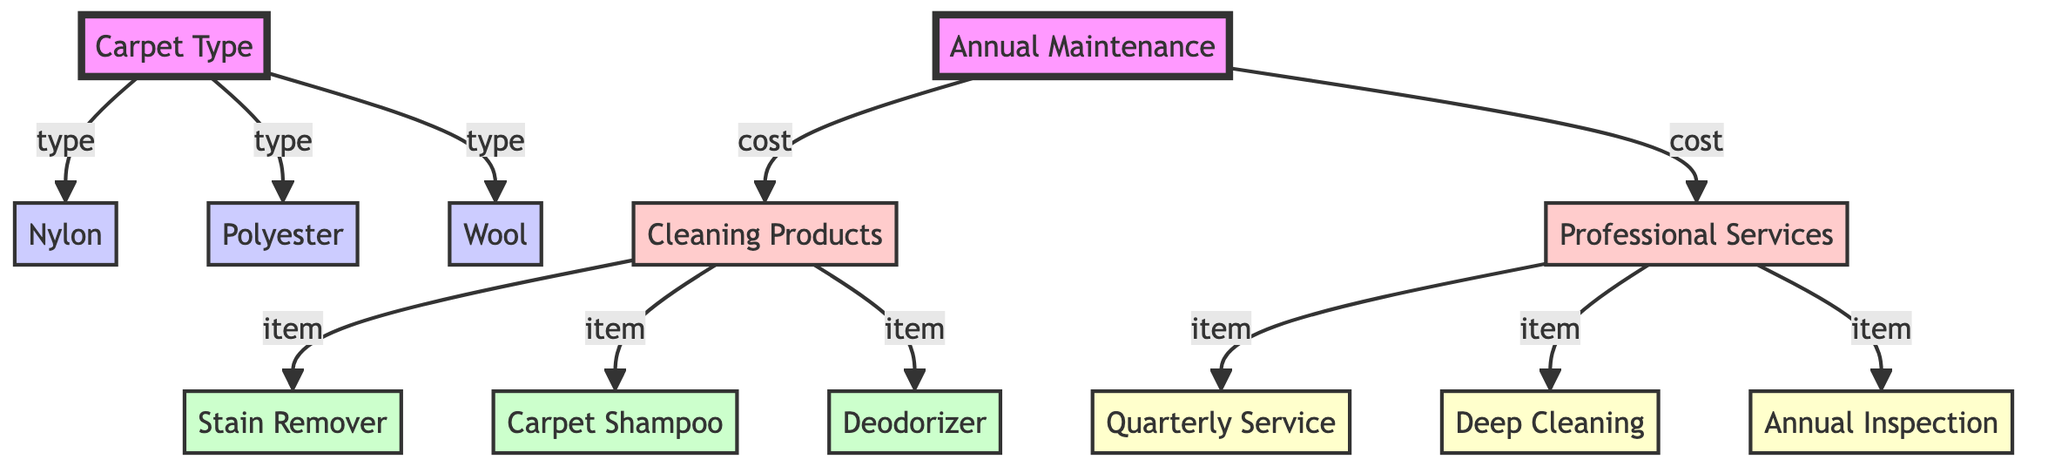what are the three types of carpets listed? The diagram lists three types of carpets: Nylon, Polyester, and Wool. Each type is represented under the main node "Carpet Type."
Answer: Nylon, Polyester, Wool how many items are listed under cleaning products? There are three items listed as cleaning products: Stain Remover, Carpet Shampoo, and Deodorizer. They are all connected directly to the "Cleaning Products" node.
Answer: 3 which carpet type has the highest maintenance cost? The diagram does not provide specific maintenance costs for each carpet type, so it cannot be determined from visual information alone. However, if one were to analyze costs outside of the diagram, that might provide insight.
Answer: Unknown what are the professional services listed? The professional services listed include Quarterly Service, Deep Cleaning, and Annual Inspection. They connect from the "Professional Services" node, indicating the maintenance procedures available.
Answer: Quarterly Service, Deep Cleaning, Annual Inspection how many total maintenance components are represented in the diagram? The total maintenance components include three cleaning products (Stain Remover, Carpet Shampoo, Deodorizer) and three professional services (Quarterly Service, Deep Cleaning, Annual Inspection), giving a sum of six components.
Answer: 6 which node serves as the main category for the cost breakdown? The main category for the cost breakdown is "Annual Maintenance". This node connects to both cleaning products and professional services, which outlines the overall maintenance strategy.
Answer: Annual Maintenance what type of cleaning product is listed first? The first cleaning product listed is Stain Remover. It appears directly linked under the "Cleaning Products" node.
Answer: Stain Remover which has more items listed, professional services or cleaning products? Both professional services and cleaning products have three items each, making the counts equal. Neither has more items than the other.
Answer: Equal 